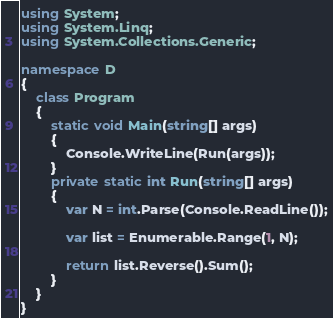Convert code to text. <code><loc_0><loc_0><loc_500><loc_500><_C#_>using System;
using System.Linq;
using System.Collections.Generic;

namespace D
{
    class Program
    {
        static void Main(string[] args)
        {
            Console.WriteLine(Run(args));
        }
        private static int Run(string[] args)
        {
            var N = int.Parse(Console.ReadLine());

            var list = Enumerable.Range(1, N);
            
            return list.Reverse().Sum();
        }
    }
}</code> 